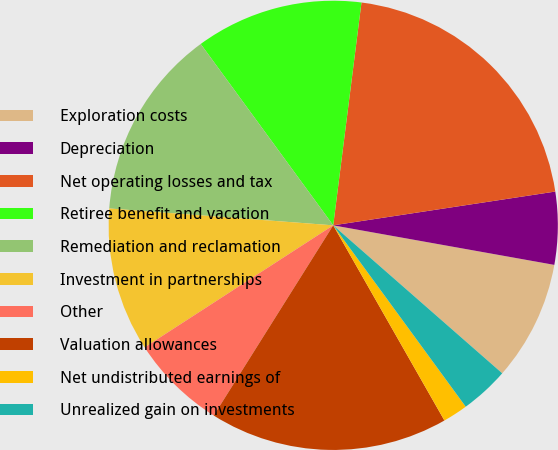Convert chart. <chart><loc_0><loc_0><loc_500><loc_500><pie_chart><fcel>Exploration costs<fcel>Depreciation<fcel>Net operating losses and tax<fcel>Retiree benefit and vacation<fcel>Remediation and reclamation<fcel>Investment in partnerships<fcel>Other<fcel>Valuation allowances<fcel>Net undistributed earnings of<fcel>Unrealized gain on investments<nl><fcel>8.63%<fcel>5.22%<fcel>20.59%<fcel>12.05%<fcel>13.76%<fcel>10.34%<fcel>6.93%<fcel>17.17%<fcel>1.8%<fcel>3.51%<nl></chart> 